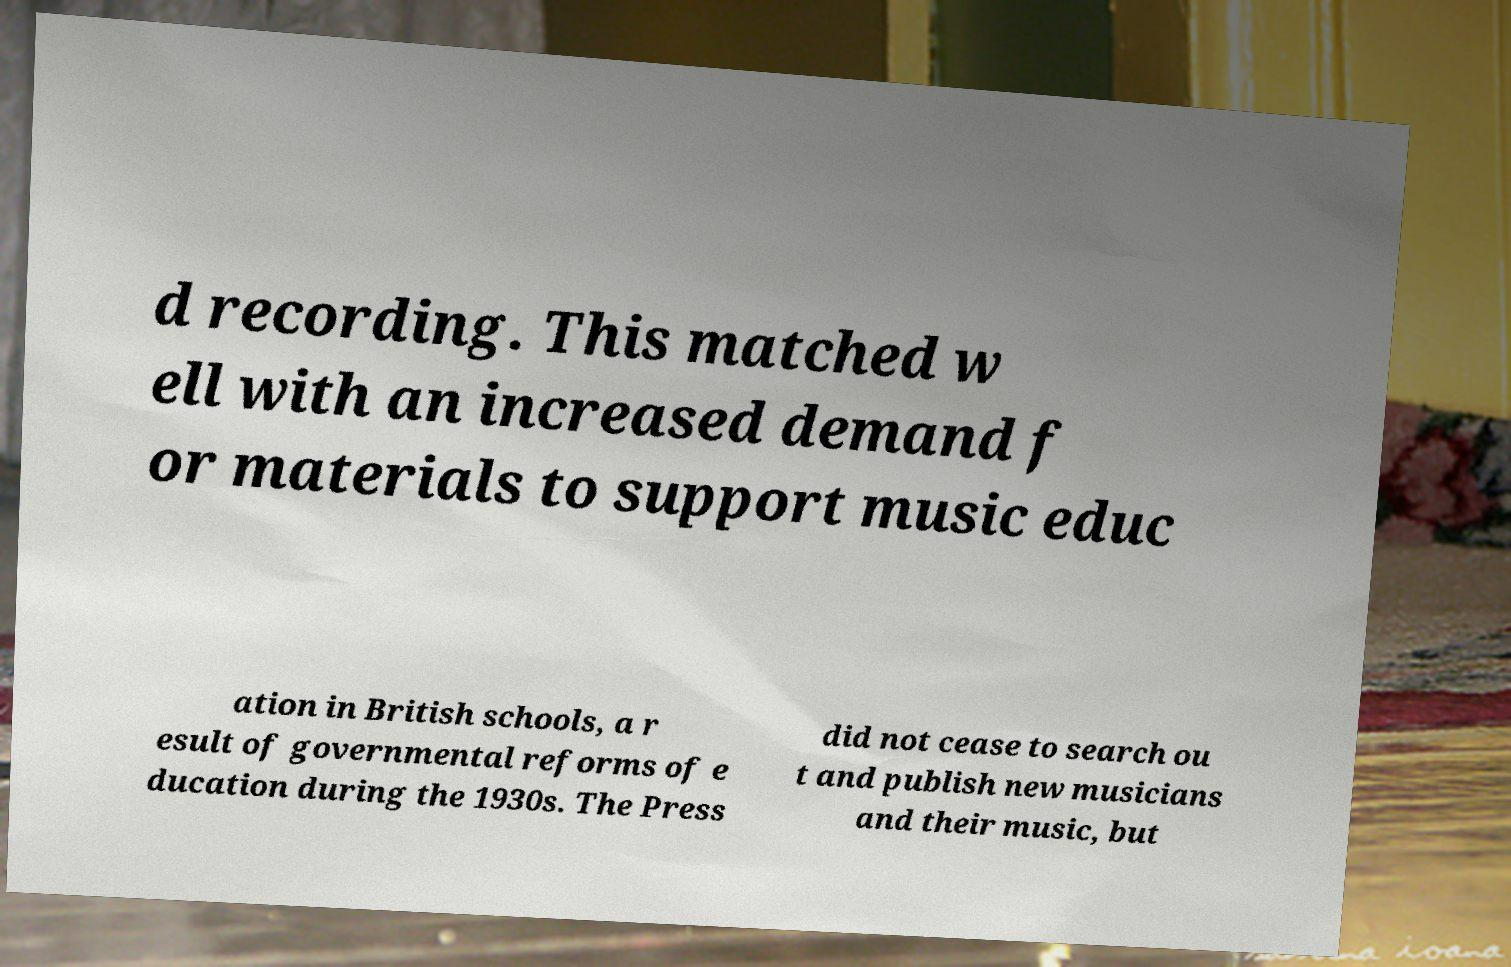Could you assist in decoding the text presented in this image and type it out clearly? d recording. This matched w ell with an increased demand f or materials to support music educ ation in British schools, a r esult of governmental reforms of e ducation during the 1930s. The Press did not cease to search ou t and publish new musicians and their music, but 